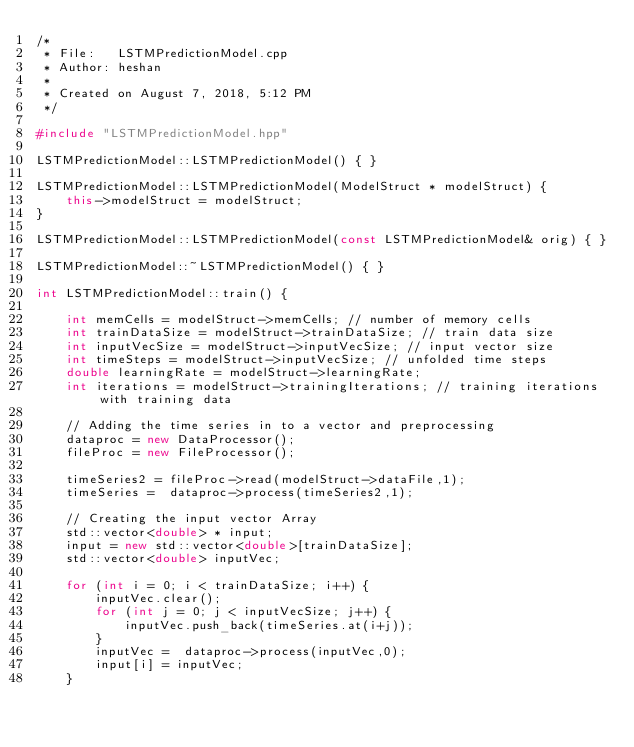Convert code to text. <code><loc_0><loc_0><loc_500><loc_500><_C++_>/* 
 * File:   LSTMPredictionModel.cpp
 * Author: heshan
 * 
 * Created on August 7, 2018, 5:12 PM
 */

#include "LSTMPredictionModel.hpp"

LSTMPredictionModel::LSTMPredictionModel() { }

LSTMPredictionModel::LSTMPredictionModel(ModelStruct * modelStruct) { 
    this->modelStruct = modelStruct;
}

LSTMPredictionModel::LSTMPredictionModel(const LSTMPredictionModel& orig) { }

LSTMPredictionModel::~LSTMPredictionModel() { }

int LSTMPredictionModel::train() {

    int memCells = modelStruct->memCells; // number of memory cells
    int trainDataSize = modelStruct->trainDataSize; // train data size
    int inputVecSize = modelStruct->inputVecSize; // input vector size
    int timeSteps = modelStruct->inputVecSize; // unfolded time steps
    double learningRate = modelStruct->learningRate;
    int iterations = modelStruct->trainingIterations; // training iterations with training data

    // Adding the time series in to a vector and preprocessing
    dataproc = new DataProcessor();
    fileProc = new FileProcessor();

    timeSeries2 = fileProc->read(modelStruct->dataFile,1);
    timeSeries =  dataproc->process(timeSeries2,1);

    // Creating the input vector Array
    std::vector<double> * input;
    input = new std::vector<double>[trainDataSize];
    std::vector<double> inputVec;

    for (int i = 0; i < trainDataSize; i++) {
        inputVec.clear();
        for (int j = 0; j < inputVecSize; j++) {
            inputVec.push_back(timeSeries.at(i+j));
        }
        inputVec =  dataproc->process(inputVec,0);
        input[i] = inputVec; 
    }

</code> 